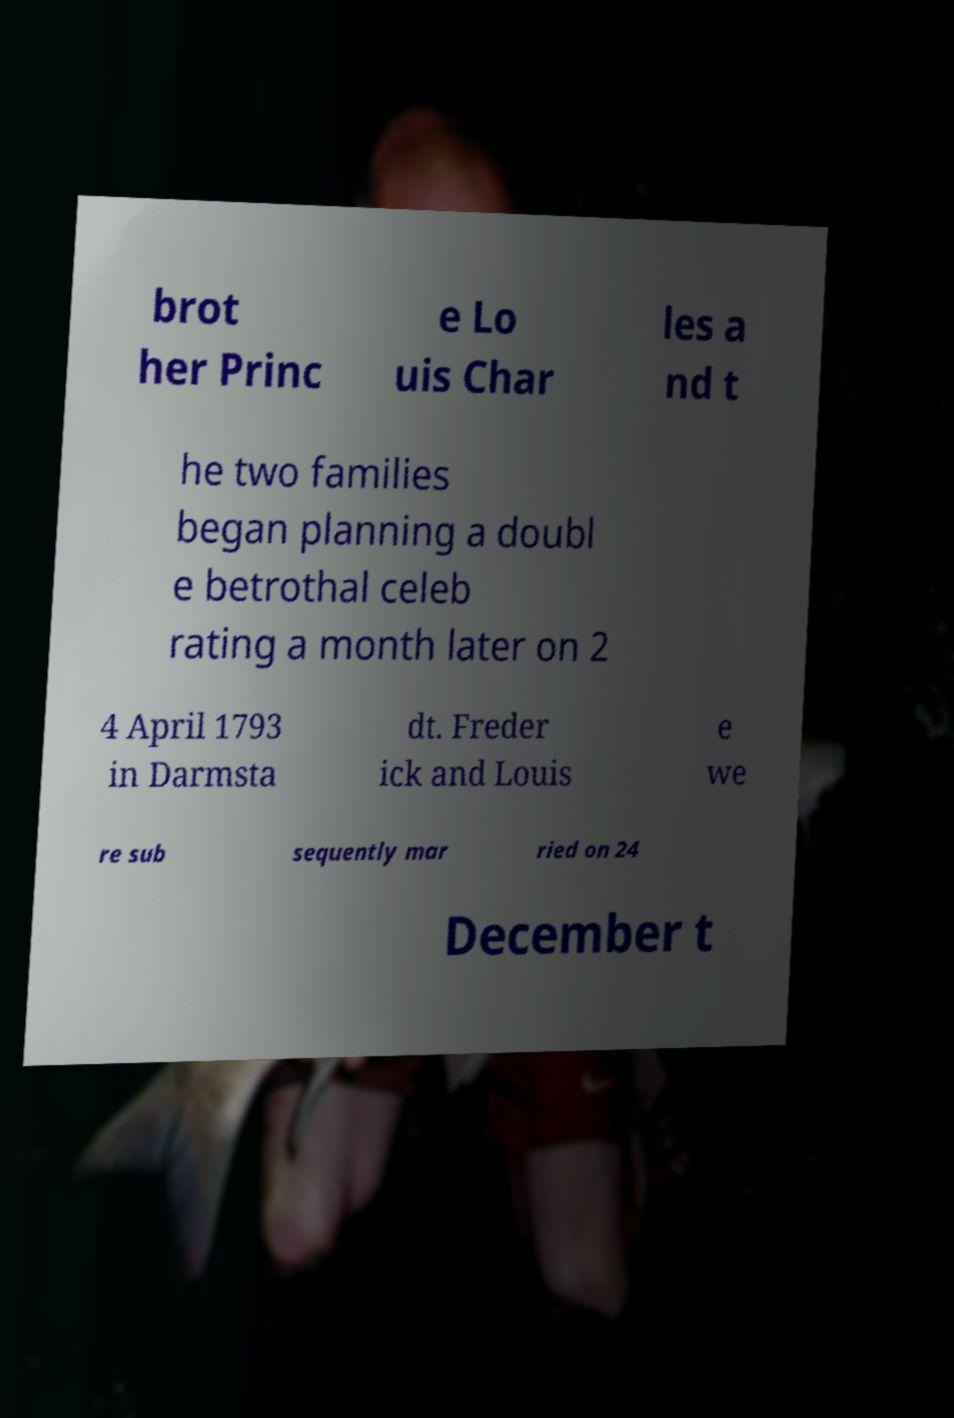Can you read and provide the text displayed in the image?This photo seems to have some interesting text. Can you extract and type it out for me? brot her Princ e Lo uis Char les a nd t he two families began planning a doubl e betrothal celeb rating a month later on 2 4 April 1793 in Darmsta dt. Freder ick and Louis e we re sub sequently mar ried on 24 December t 